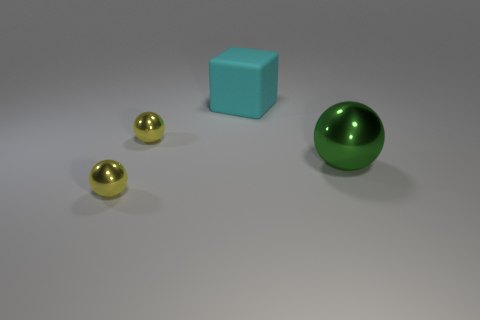Subtract all small yellow shiny spheres. How many spheres are left? 1 Subtract all yellow spheres. How many spheres are left? 1 Add 1 tiny yellow shiny spheres. How many objects exist? 5 Subtract all spheres. How many objects are left? 1 Subtract 2 balls. How many balls are left? 1 Subtract all gray cylinders. How many yellow spheres are left? 2 Subtract all large cyan matte blocks. Subtract all green balls. How many objects are left? 2 Add 4 cyan things. How many cyan things are left? 5 Add 3 small spheres. How many small spheres exist? 5 Subtract 0 gray spheres. How many objects are left? 4 